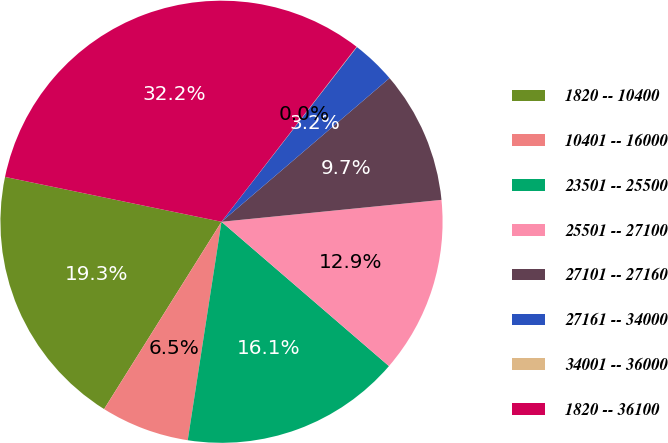Convert chart to OTSL. <chart><loc_0><loc_0><loc_500><loc_500><pie_chart><fcel>1820 -- 10400<fcel>10401 -- 16000<fcel>23501 -- 25500<fcel>25501 -- 27100<fcel>27101 -- 27160<fcel>27161 -- 34000<fcel>34001 -- 36000<fcel>1820 -- 36100<nl><fcel>19.34%<fcel>6.47%<fcel>16.12%<fcel>12.9%<fcel>9.68%<fcel>3.25%<fcel>0.03%<fcel>32.21%<nl></chart> 